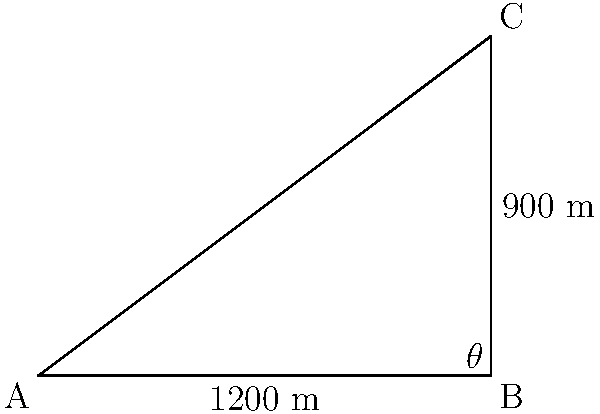You're planning a directional drilling path for a new well. The total horizontal displacement is 1200 m, and the vertical depth reached is 900 m. What is the angle of inclination ($\theta$) for this drilling path? To solve this problem, we can use trigonometry in a right triangle:

1) The horizontal displacement forms the base of the triangle (adjacent to the angle $\theta$).
2) The vertical depth forms the height of the triangle (opposite to the angle $\theta$).
3) We need to find the angle $\theta$ using the tangent function.

Step 1: Identify the known values
- Adjacent (horizontal displacement) = 1200 m
- Opposite (vertical depth) = 900 m

Step 2: Use the tangent function
$\tan(\theta) = \frac{\text{opposite}}{\text{adjacent}}$

Step 3: Substitute the known values
$\tan(\theta) = \frac{900}{1200}$

Step 4: Simplify
$\tan(\theta) = 0.75$

Step 5: Solve for $\theta$ using the inverse tangent function
$\theta = \tan^{-1}(0.75)$

Step 6: Calculate the result
$\theta \approx 36.87°$

Therefore, the angle of inclination for the drilling path is approximately 36.87°.
Answer: $36.87°$ 